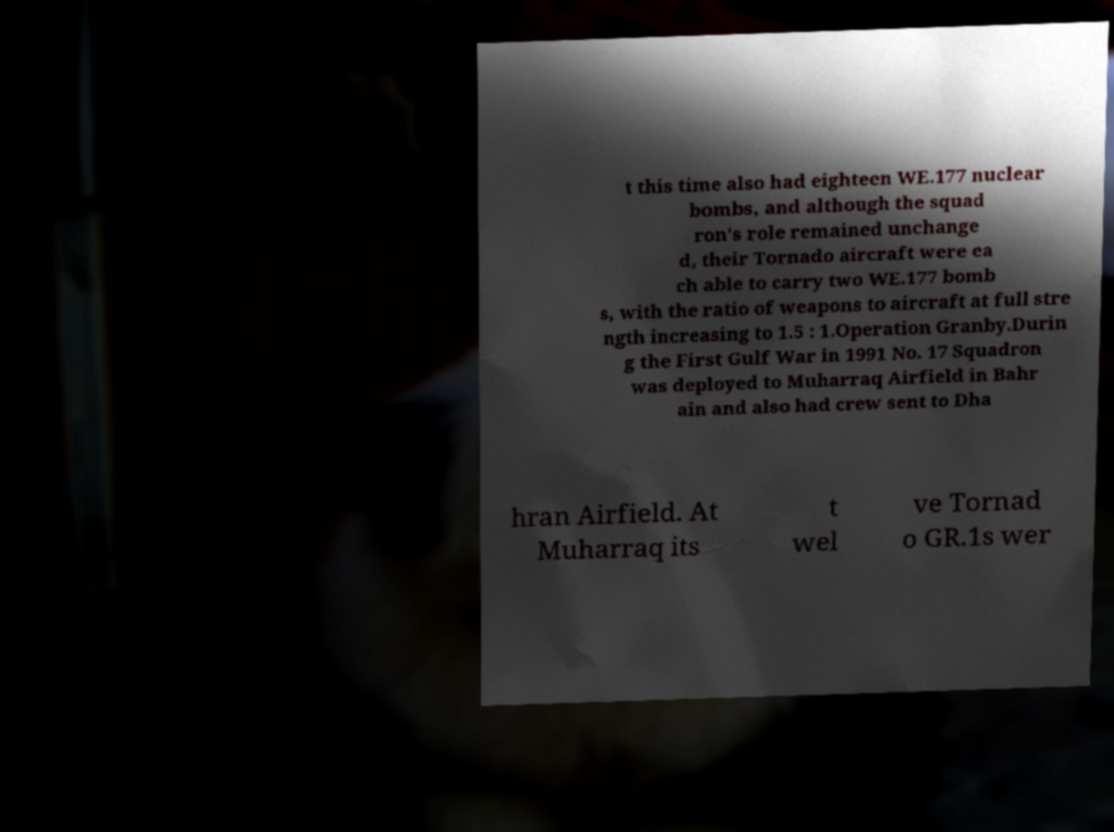Please identify and transcribe the text found in this image. t this time also had eighteen WE.177 nuclear bombs, and although the squad ron's role remained unchange d, their Tornado aircraft were ea ch able to carry two WE.177 bomb s, with the ratio of weapons to aircraft at full stre ngth increasing to 1.5 : 1.Operation Granby.Durin g the First Gulf War in 1991 No. 17 Squadron was deployed to Muharraq Airfield in Bahr ain and also had crew sent to Dha hran Airfield. At Muharraq its t wel ve Tornad o GR.1s wer 